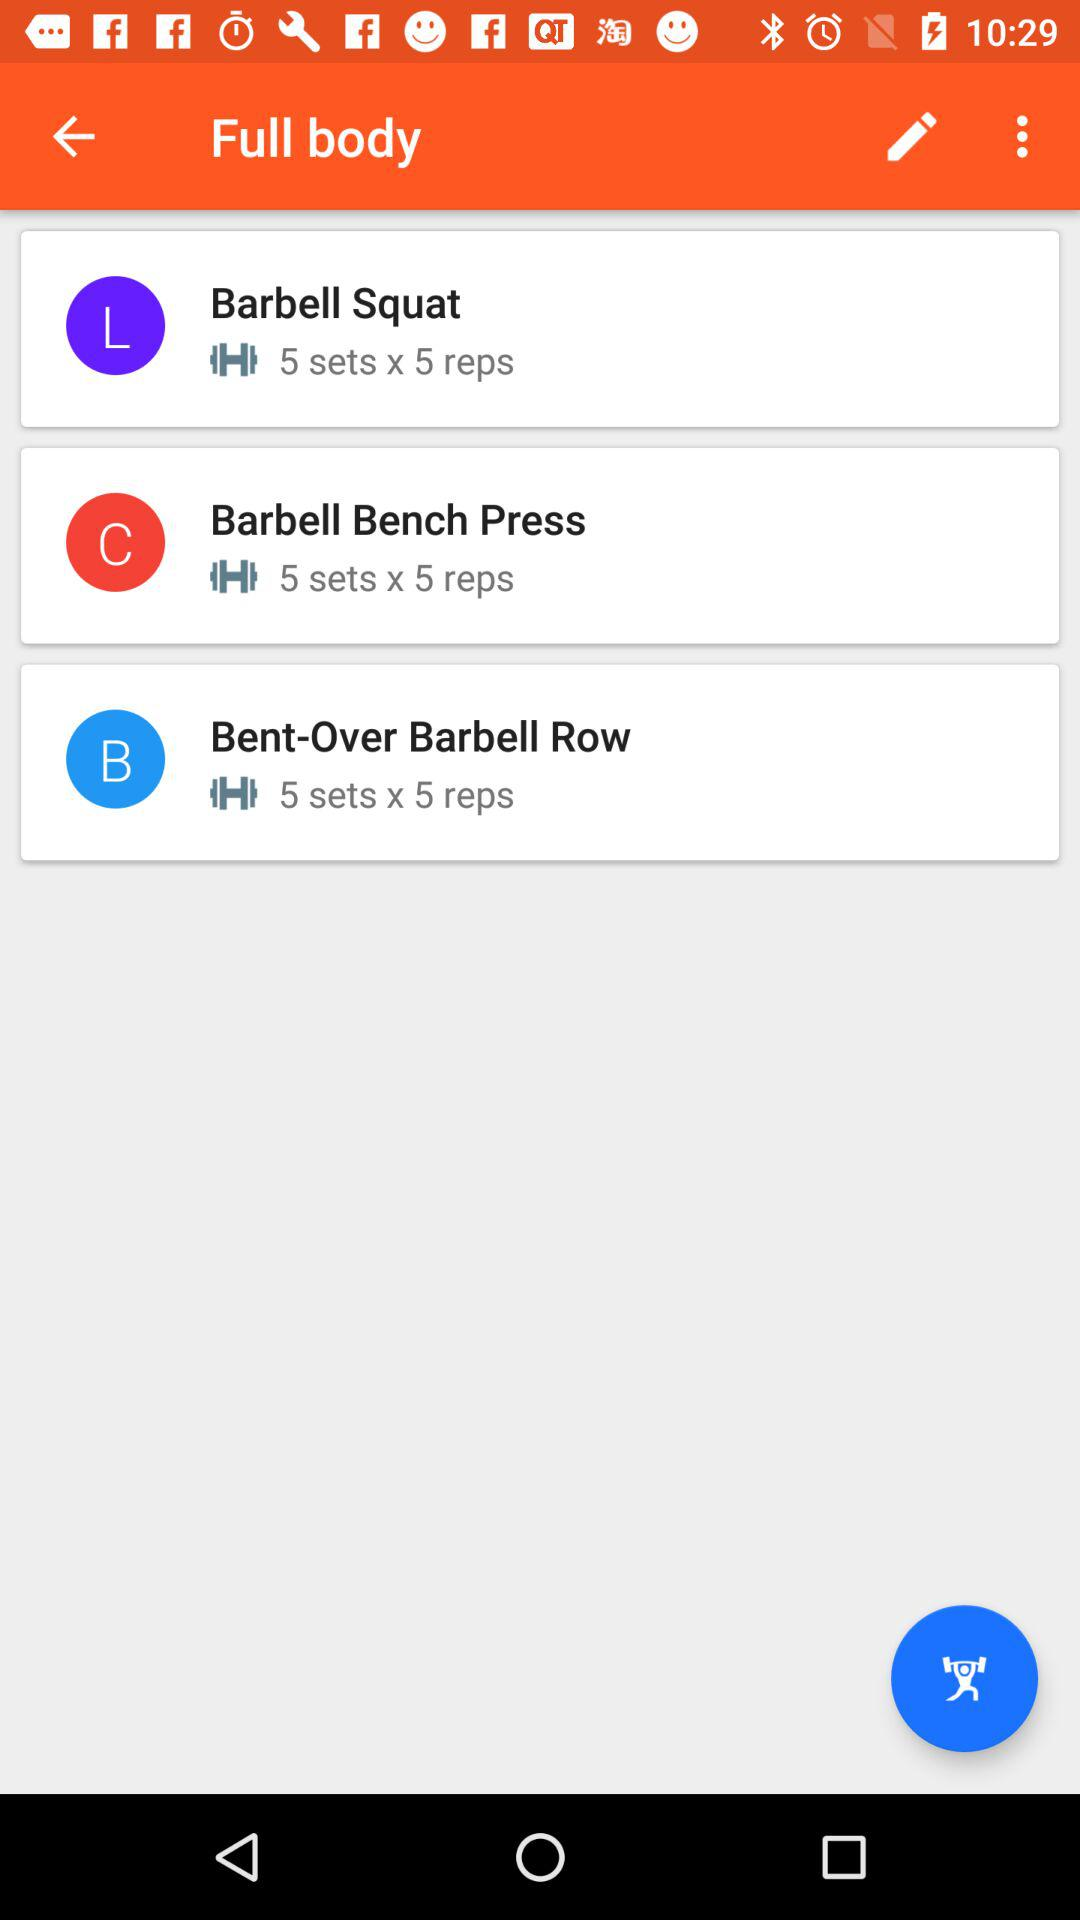How many sets are there for barbell squat? There are 5 sets for the barbell squat. 